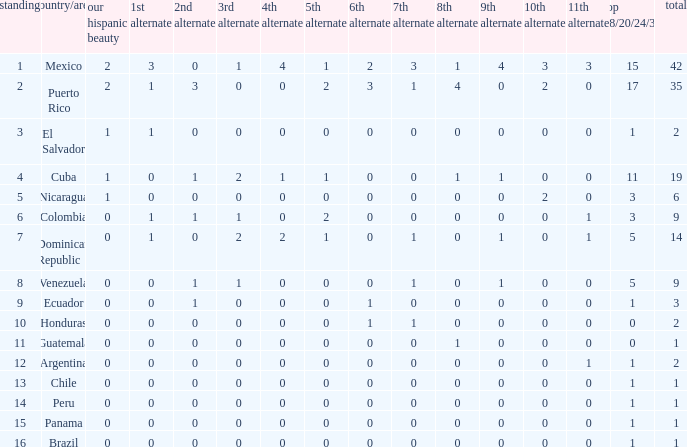What is the total number of 3rd runners-up of the country ranked lower than 12 with a 10th runner-up of 0, an 8th runner-up less than 1, and a 7th runner-up of 0? 4.0. 